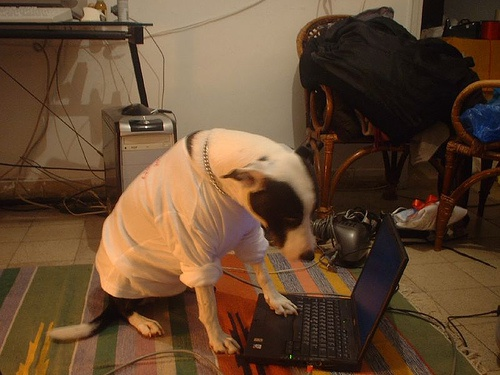Describe the objects in this image and their specific colors. I can see dog in maroon, tan, black, brown, and gray tones, chair in maroon, black, and brown tones, chair in maroon, black, and navy tones, keyboard in maroon, black, and gray tones, and keyboard in maroon, gray, and black tones in this image. 